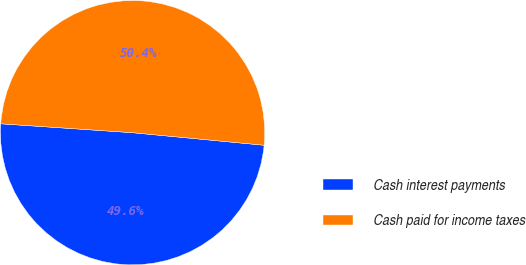Convert chart to OTSL. <chart><loc_0><loc_0><loc_500><loc_500><pie_chart><fcel>Cash interest payments<fcel>Cash paid for income taxes<nl><fcel>49.56%<fcel>50.44%<nl></chart> 